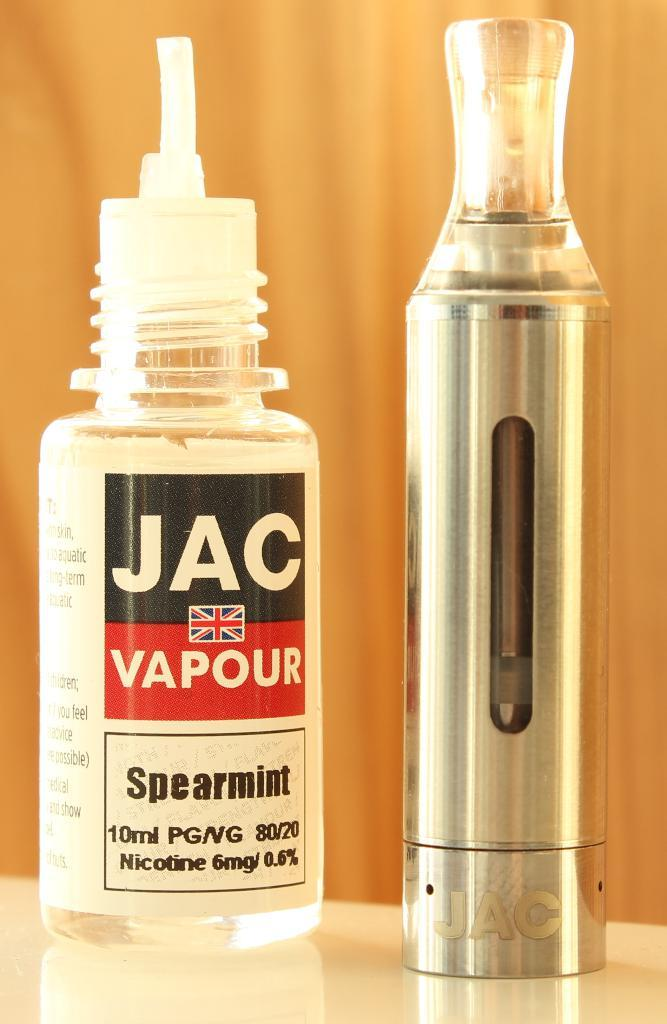Provide a one-sentence caption for the provided image. Jac Vapour spearmint that contains nicotine inside the bottle. 